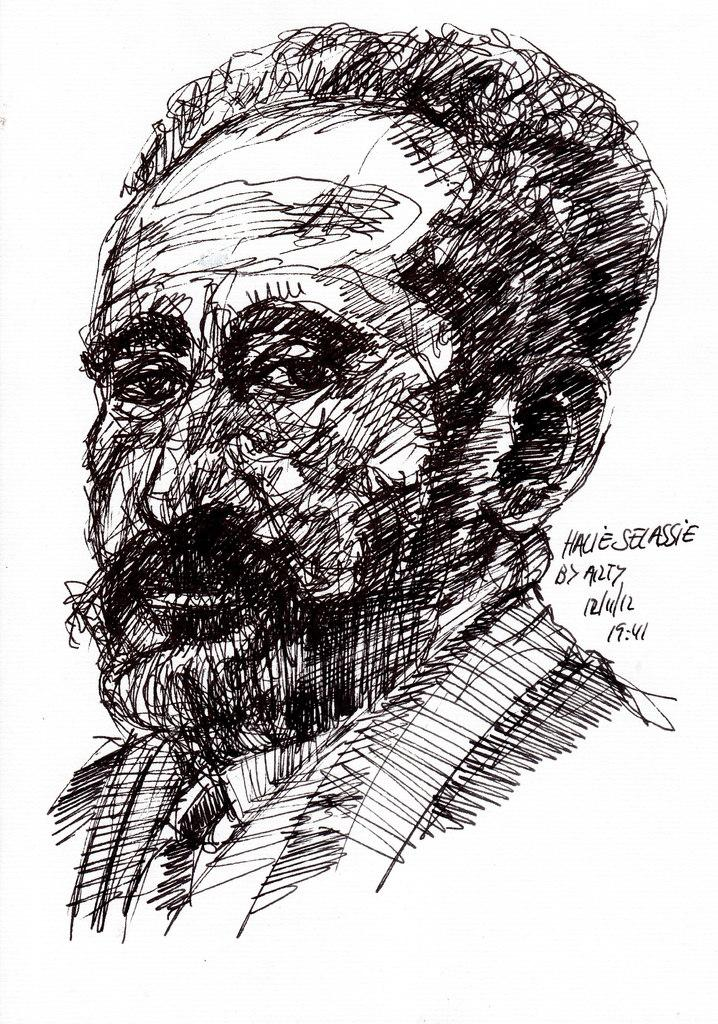What is the main subject of the image? There is a drawing of a person in the center of the image. What else can be found in the image besides the drawing of the person? There is text written in the image. What type of soda is being advertised in the image? There is no soda or advertisement present in the image; it features a drawing of a person and text. 